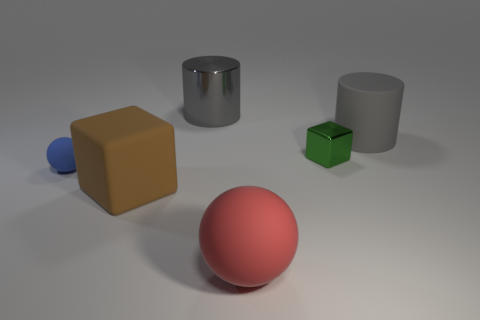Add 2 tiny red metallic cubes. How many objects exist? 8 Subtract all cylinders. How many objects are left? 4 Add 1 large brown rubber blocks. How many large brown rubber blocks exist? 2 Subtract 0 cyan blocks. How many objects are left? 6 Subtract all large things. Subtract all red spheres. How many objects are left? 1 Add 1 blocks. How many blocks are left? 3 